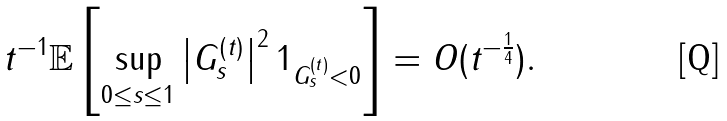Convert formula to latex. <formula><loc_0><loc_0><loc_500><loc_500>t ^ { - 1 } \mathbb { E } \left [ \sup _ { 0 \leq s \leq 1 } \left | G _ { s } ^ { ( t ) } \right | ^ { 2 } 1 _ { G _ { s } ^ { ( t ) } < 0 } \right ] = O ( t ^ { - \frac { 1 } { 4 } } ) .</formula> 